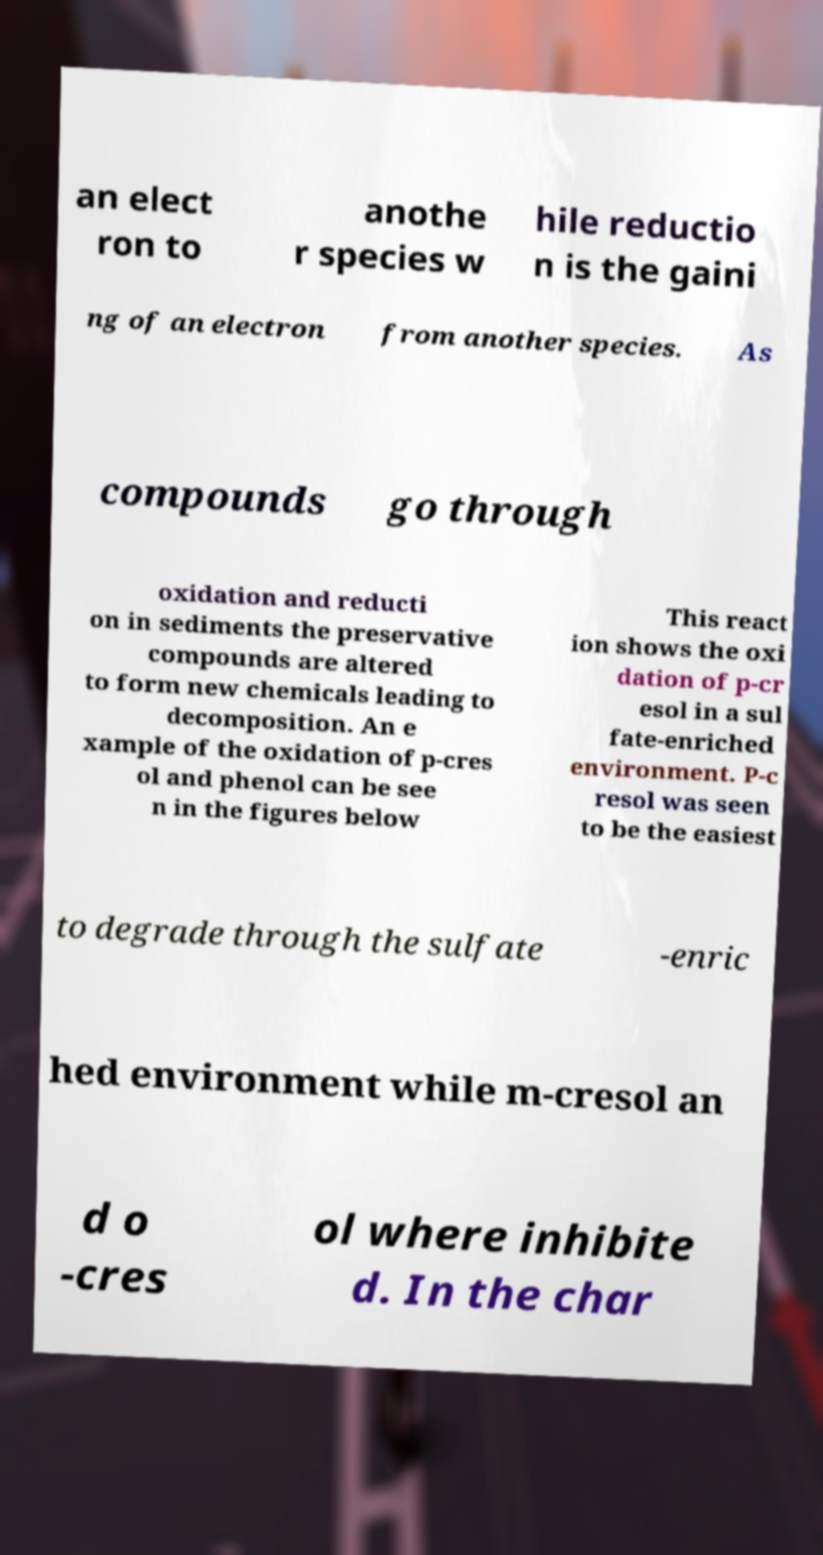For documentation purposes, I need the text within this image transcribed. Could you provide that? an elect ron to anothe r species w hile reductio n is the gaini ng of an electron from another species. As compounds go through oxidation and reducti on in sediments the preservative compounds are altered to form new chemicals leading to decomposition. An e xample of the oxidation of p-cres ol and phenol can be see n in the figures below This react ion shows the oxi dation of p-cr esol in a sul fate-enriched environment. P-c resol was seen to be the easiest to degrade through the sulfate -enric hed environment while m-cresol an d o -cres ol where inhibite d. In the char 